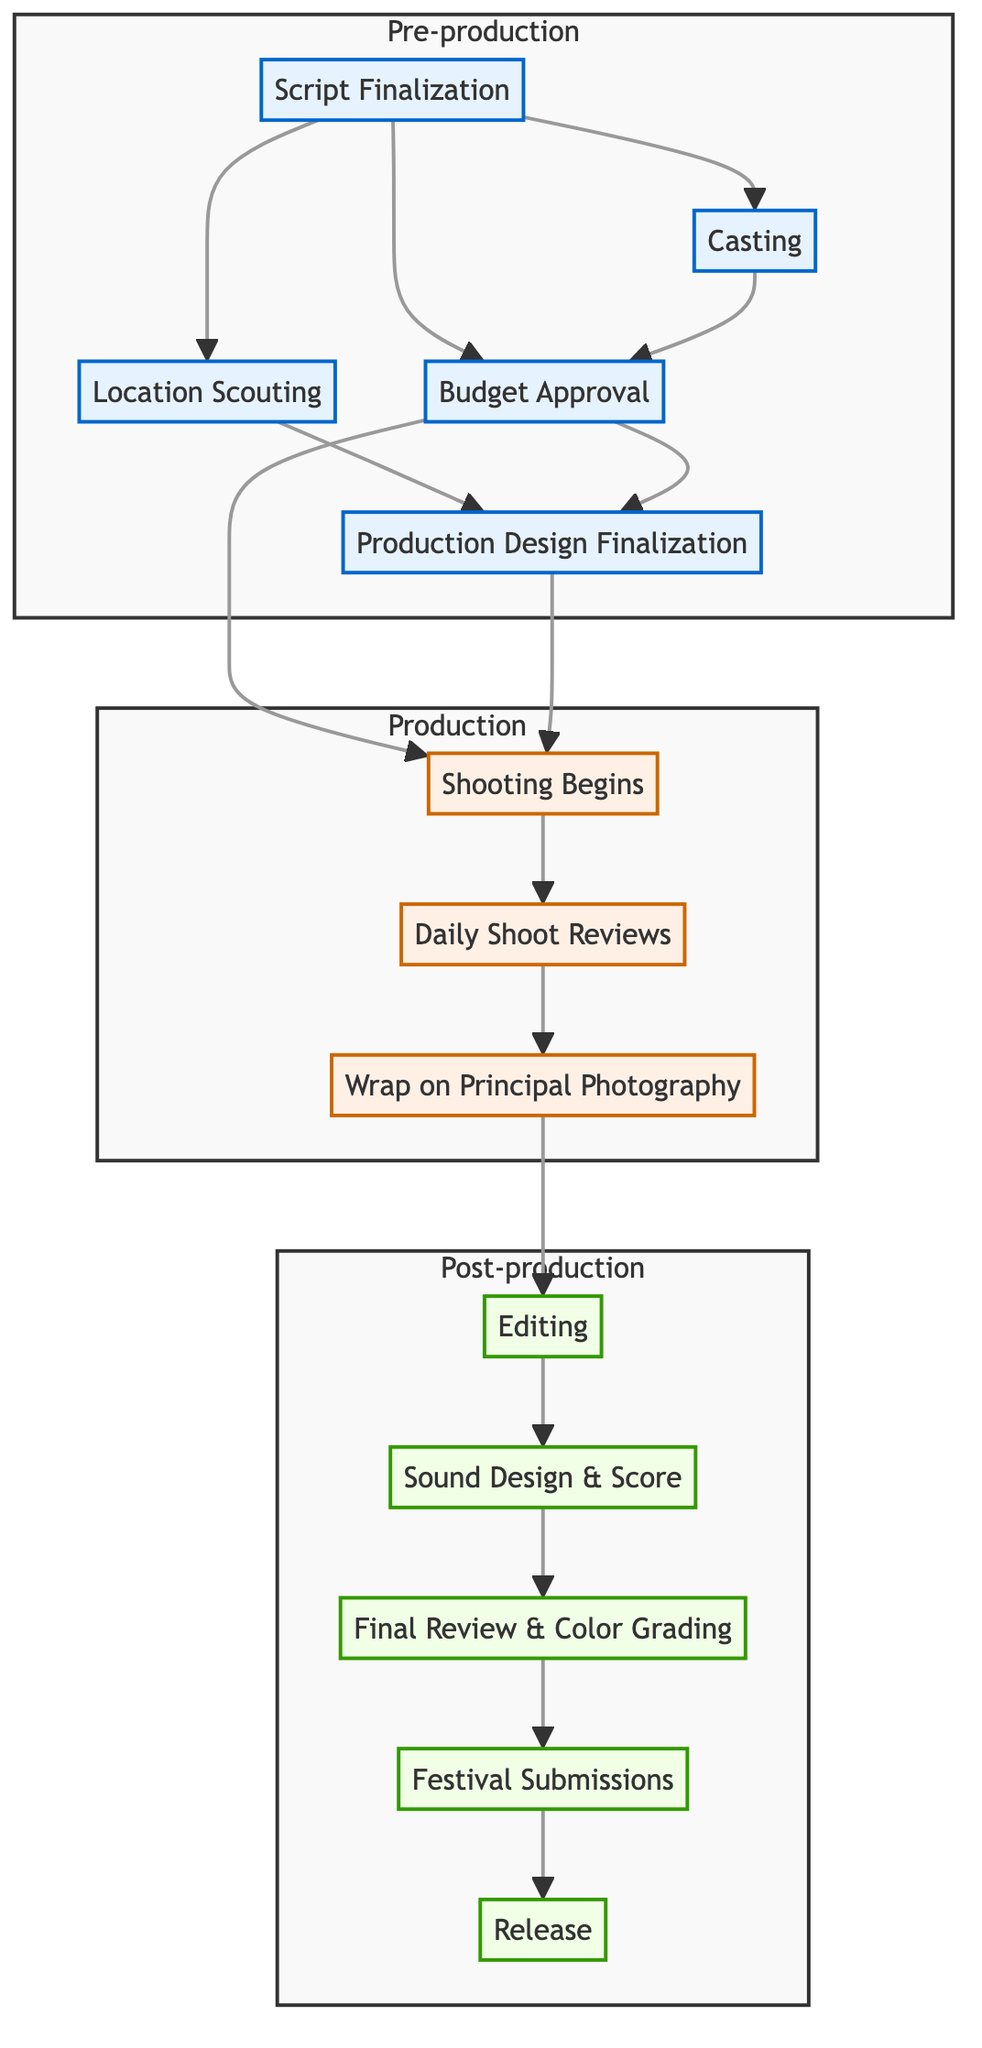What is the first milestone in pre-production? The first milestone listed in pre-production is "Script Finalization," which has no dependencies. Thus, it comes at the start of the process.
Answer: Script Finalization How many milestones are in the production phase? There are three milestones listed in the production phase: "Shooting Begins," "Daily Shoot Reviews," and "Wrap on Principal Photography." Counting these gives a total of three.
Answer: 3 What milestone directly follows "Wrap on Principal Photography"? The milestone that follows "Wrap on Principal Photography" is "Editing." This is clear as "Editing" has a direct dependency on completion of "Wrap on Principal Photography."
Answer: Editing What are the dependencies for "Budget Approval"? "Budget Approval" depends on "Script Finalization" and "Casting," meaning both of these must be completed before "Budget Approval" can be achieved.
Answer: Script Finalization, Casting Which two milestones must be completed before "Shooting Begins"? Before "Shooting Begins," the milestones that must be completed are "Budget Approval" and "Production Design Finalization." This is indicated by the dependencies listed for "Shooting Begins."
Answer: Budget Approval, Production Design Finalization How many milestones in total are presented in the diagram? By totaling the milestones across the three phases—five in pre-production, three in production, and five in post-production—we find a total of 13 milestones.
Answer: 13 What is the last milestone in the entire production schedule? The last milestone in the production schedule is "Release," which is the final step after "Festival Submissions." This shows that "Release" is the culmination of all preceding tasks.
Answer: Release What milestone has the dependency of "Editing"? The milestone that depends on "Editing" is "Sound Design & Score." Understanding the dependencies shows that "Sound Design & Score" cannot begin until "Editing" is complete.
Answer: Sound Design & Score Which phase includes "Location Scouting"? "Location Scouting" is a milestone in the pre-production phase. This can be seen from the organization of the milestones within the different phases in the diagram.
Answer: Pre-production 